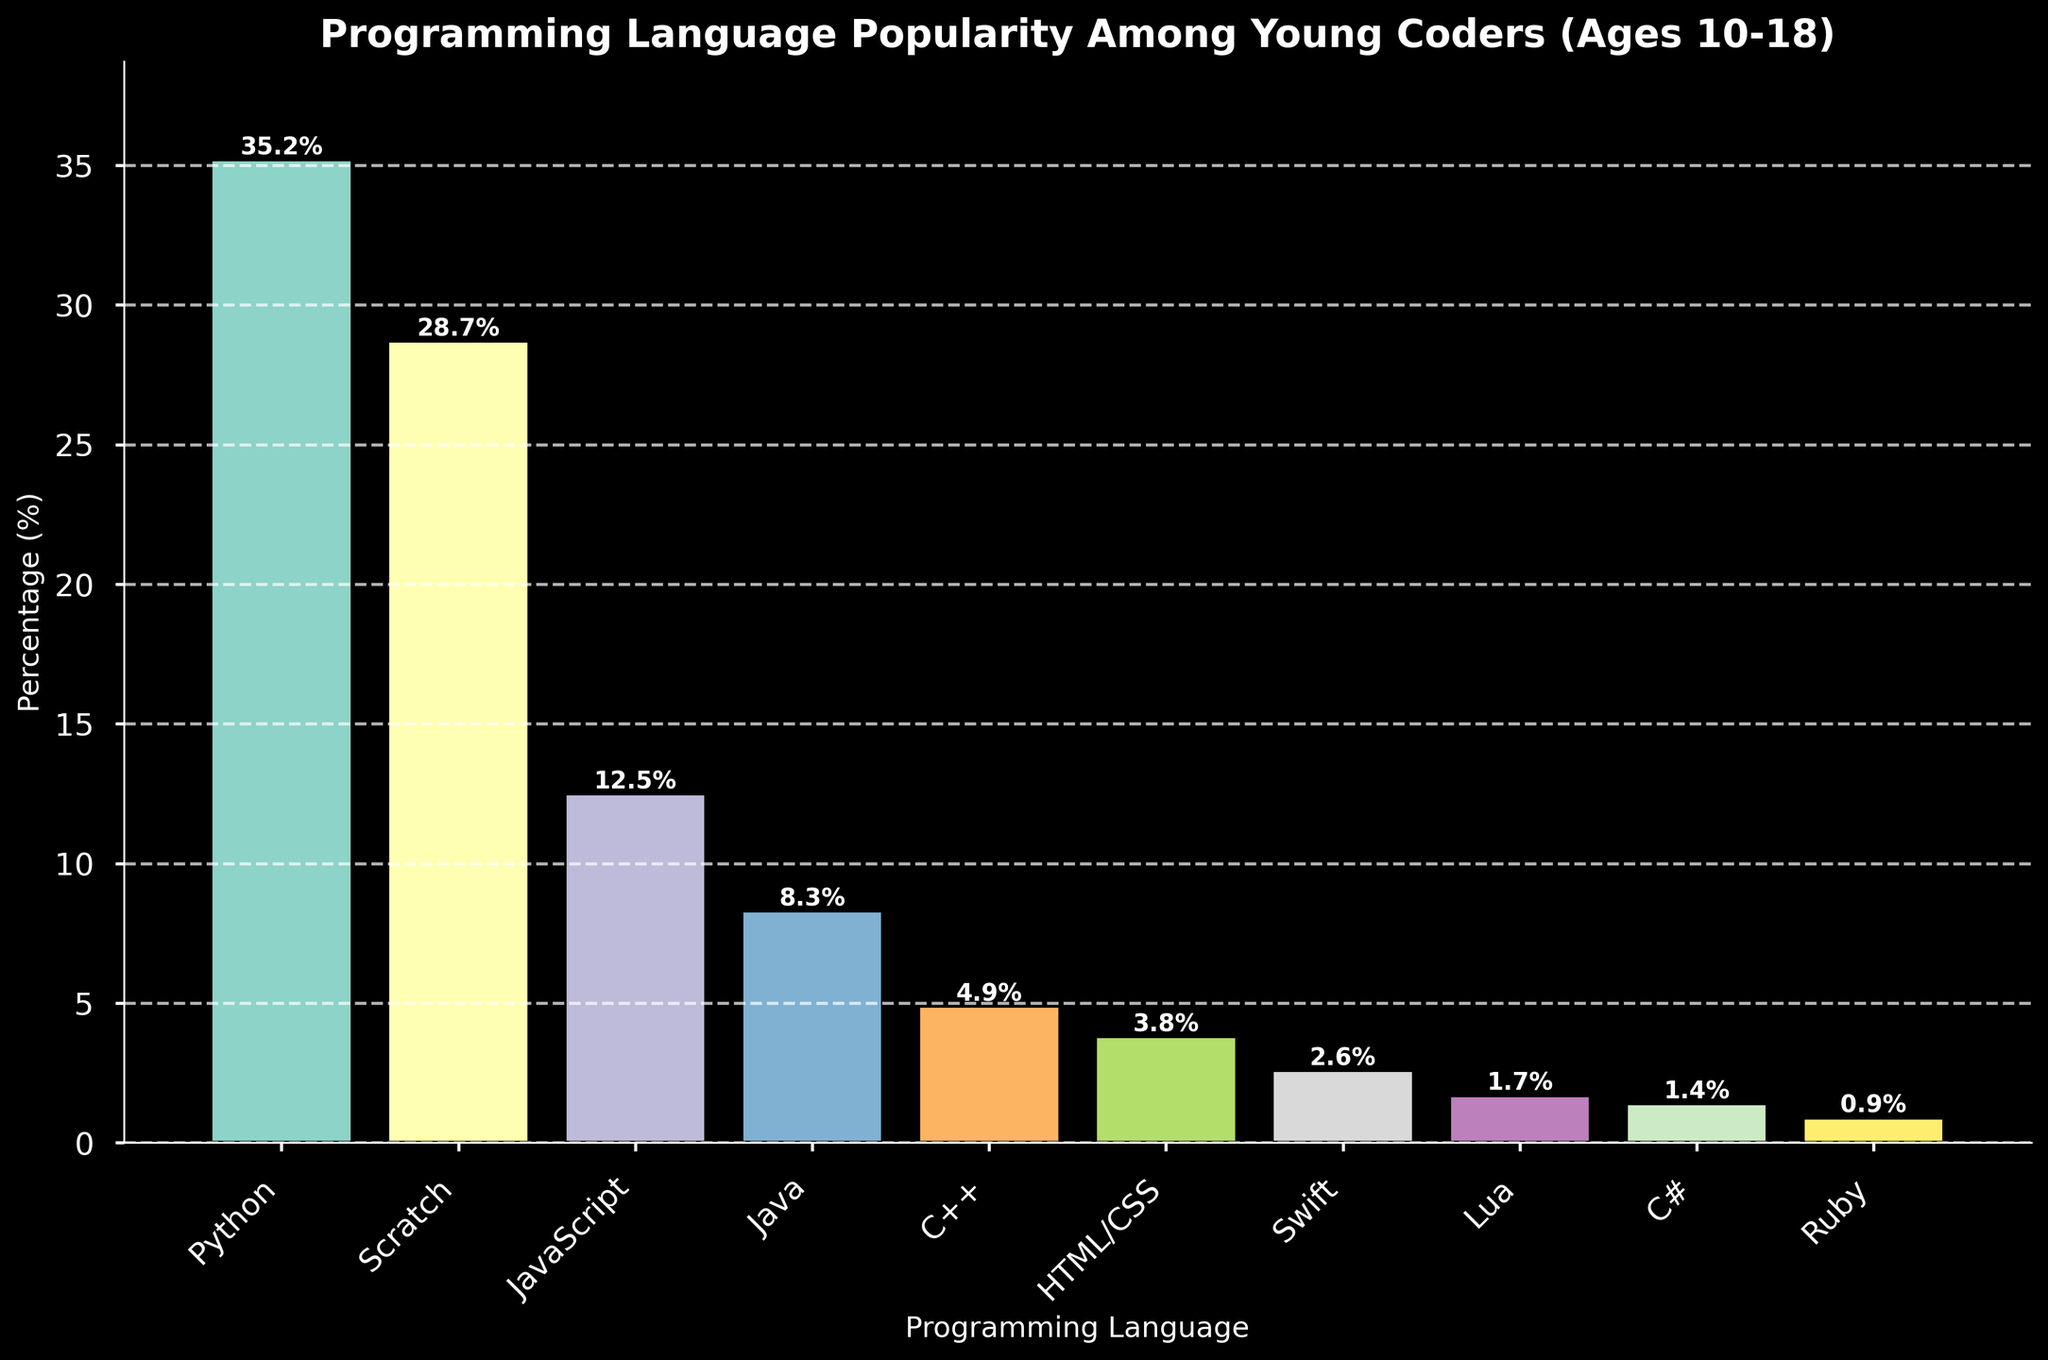What's the most popular programming language among young coders? To find the most popular language, look for the bar with the greatest height. Python has the highest bar, indicating it has the highest percentage.
Answer: Python Which programming language is more popular: Java or C++? Compare the heights of the bars representing Java and C++. Java's bar is taller at 8.3%, whereas C++ is at 4.9%.
Answer: Java How much more popular is Python compared to JavaScript? Python has a percentage of 35.2% and JavaScript has 12.5%. Subtract the smaller percentage from the larger: 35.2% - 12.5% = 22.7%.
Answer: 22.7% What is the percentage difference between Scratch and HTML/CSS? Scratch has a percentage of 28.7% and HTML/CSS has 3.8%. Subtract the smaller percentage from the larger: 28.7% - 3.8% = 24.9%.
Answer: 24.9% Which language is ranked third in popularity? From the tallest to the third tallest bar, the order is: Python (35.2%), Scratch (28.7%), and JavaScript (12.5%). The third bar in terms of height is JavaScript.
Answer: JavaScript What is the combined percentage of the three least popular programming languages? The percentages for the least popular languages are Ruby (0.9%), C# (1.4%), and Lua (1.7%). Adding these together: 0.9% + 1.4% + 1.7% = 4.0%.
Answer: 4.0% Is Swift more popular than Lua? Compare the heights of the Swift and Lua bars. Swift is taller with 2.6%, Lua has 1.7%.
Answer: Yes How many programming languages have a popularity percentage greater than or equal to 5%? Identify all bars with heights 5% or higher: Python (35.2%), Scratch (28.7%), and JavaScript (12.5%), Java (8.3%). There are four such languages.
Answer: 4 What is the average popularity percentage of Java, C++, and Swift? The percentages are Java (8.3%), C++ (4.9%), and Swift (2.6%). Calculate the average: (8.3% + 4.9% + 2.6%) / 3 ≈ 5.27%.
Answer: 5.3% Which language has a percentage close to 15%? Identify the bar heights close to 15%. None of the bars match exactly 15%, but JavaScript is closest at 12.5%.
Answer: JavaScript 